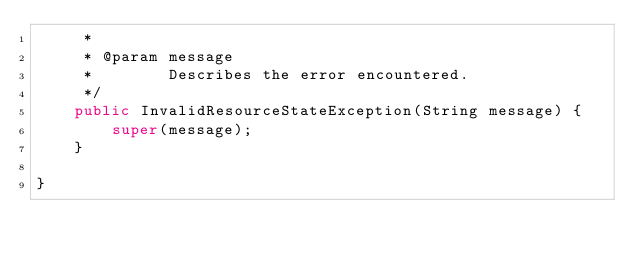Convert code to text. <code><loc_0><loc_0><loc_500><loc_500><_Java_>     *
     * @param message
     *        Describes the error encountered.
     */
    public InvalidResourceStateException(String message) {
        super(message);
    }

}
</code> 